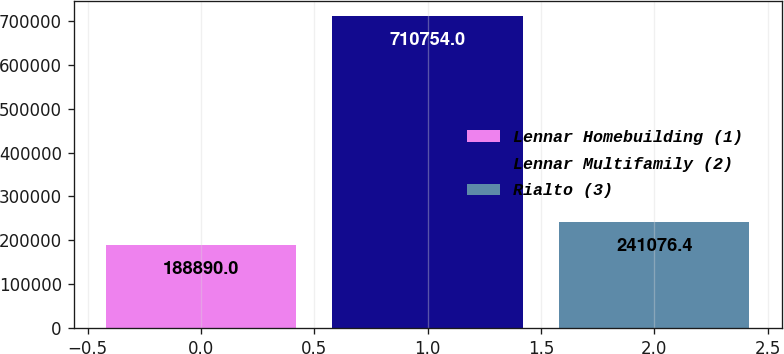<chart> <loc_0><loc_0><loc_500><loc_500><bar_chart><fcel>Lennar Homebuilding (1)<fcel>Lennar Multifamily (2)<fcel>Rialto (3)<nl><fcel>188890<fcel>710754<fcel>241076<nl></chart> 